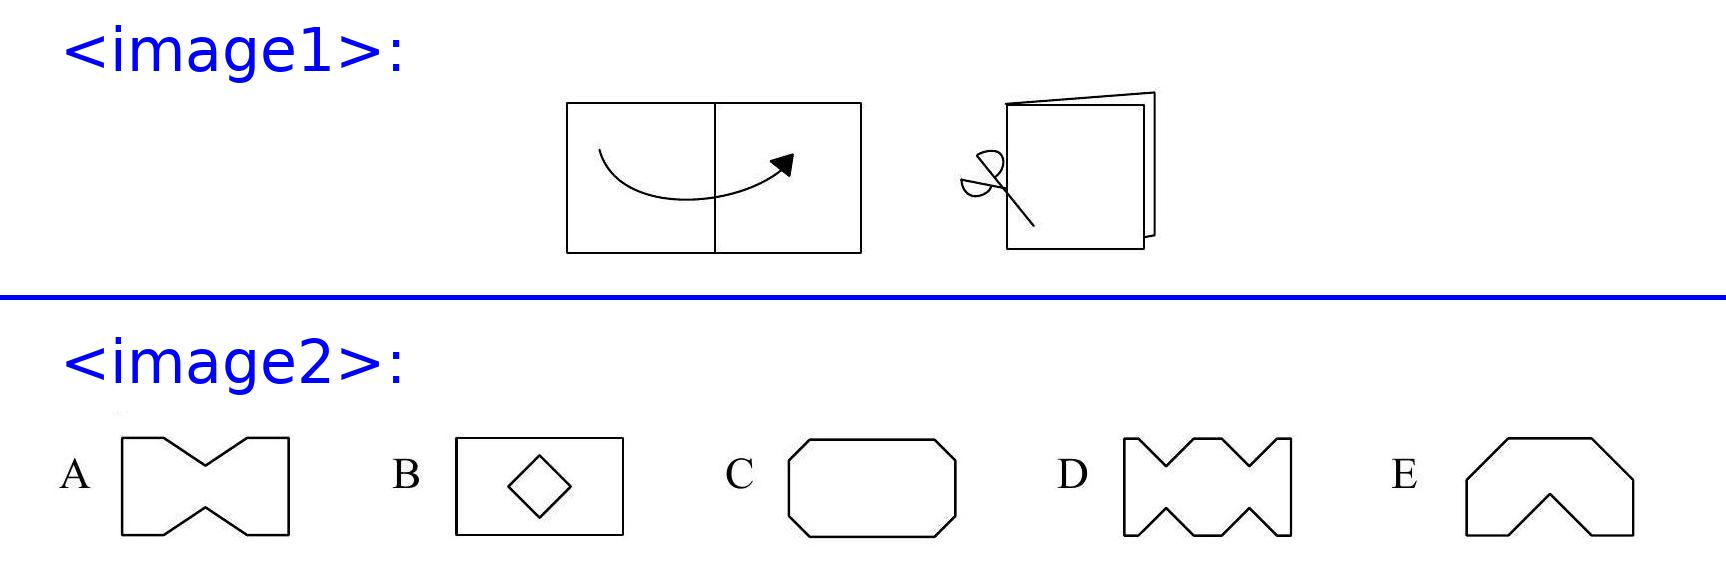<image1> What is the direction of the fold in the paper and how does it affect the resulting shapes? The paper is folded along the horizontal axis. This type of fold results in symmetrical shapes upon cutting and unfolding, as each cut affects both layers equally due to the symmetry of the fold. And what could be the approximate measurements for one of the cuts to achieve shape C? To achieve shape C, one might consider making a straight, horizontal cut along the bottom of the folded paper, approximately one-third of the way from either side, meeting in the center. This allows the paper to unfold into the elongated shape seen in option C. 